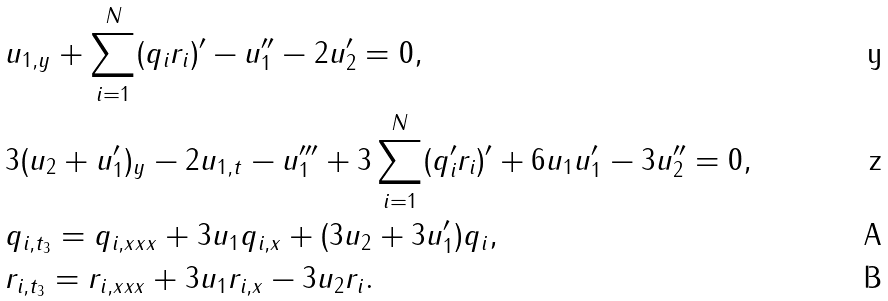Convert formula to latex. <formula><loc_0><loc_0><loc_500><loc_500>& u _ { 1 , y } + \sum _ { i = 1 } ^ { N } ( q _ { i } r _ { i } ) ^ { \prime } - u _ { 1 } ^ { \prime \prime } - 2 u _ { 2 } ^ { \prime } = 0 , \\ & 3 ( u _ { 2 } + u _ { 1 } ^ { \prime } ) _ { y } - 2 u _ { 1 , t } - u _ { 1 } ^ { \prime \prime \prime } + 3 \sum _ { i = 1 } ^ { N } ( q _ { i } ^ { \prime } r _ { i } ) ^ { \prime } + 6 u _ { 1 } u _ { 1 } ^ { \prime } - 3 u _ { 2 } ^ { \prime \prime } = 0 , \\ & q _ { i , t _ { 3 } } = q _ { i , x x x } + 3 u _ { 1 } q _ { i , x } + ( 3 u _ { 2 } + 3 u _ { 1 } ^ { \prime } ) q _ { i } , \\ & r _ { i , t _ { 3 } } = r _ { i , x x x } + 3 u _ { 1 } r _ { i , x } - 3 u _ { 2 } r _ { i } .</formula> 